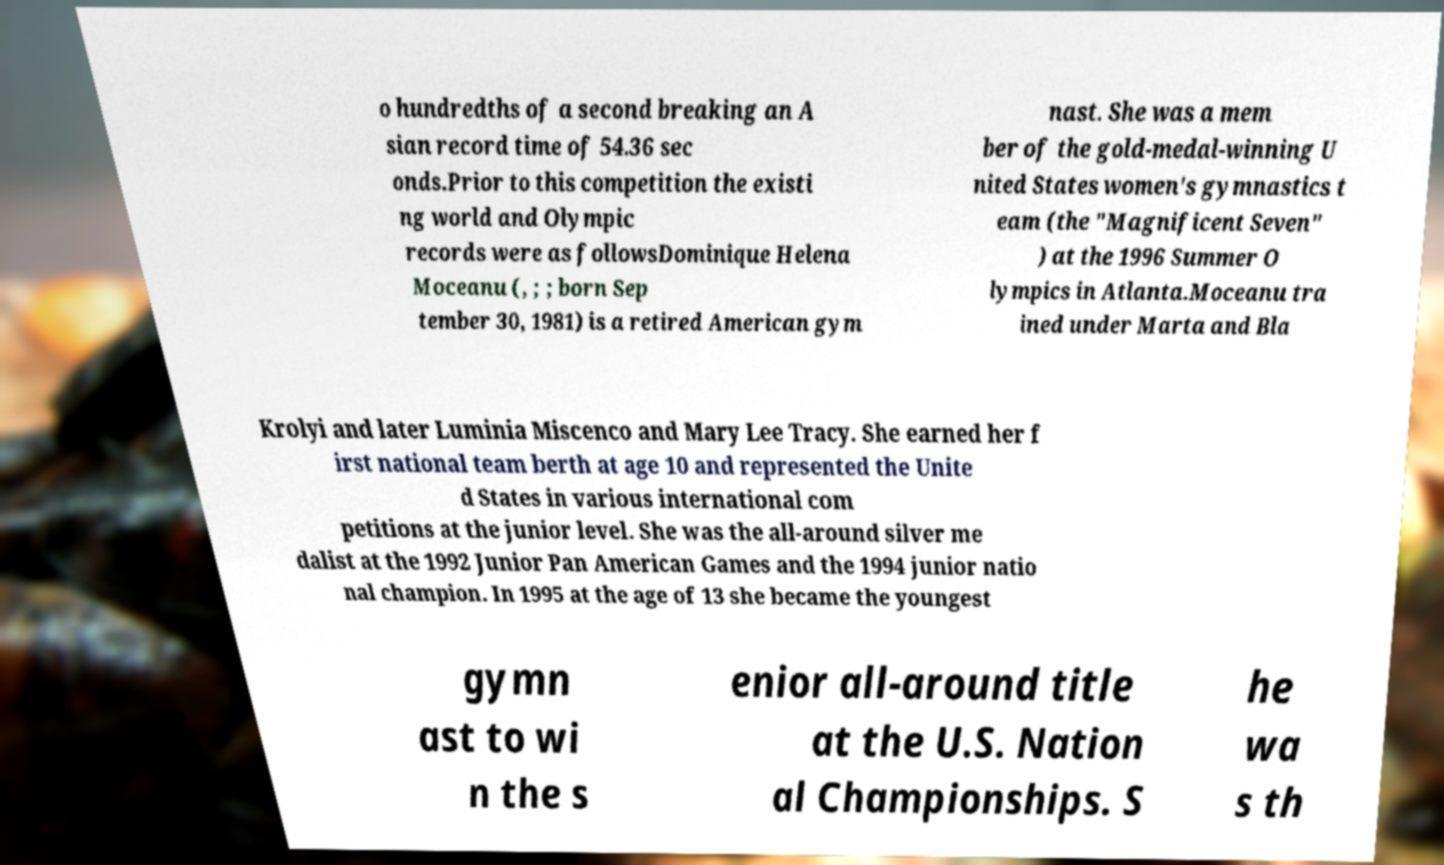What messages or text are displayed in this image? I need them in a readable, typed format. o hundredths of a second breaking an A sian record time of 54.36 sec onds.Prior to this competition the existi ng world and Olympic records were as followsDominique Helena Moceanu (, ; ; born Sep tember 30, 1981) is a retired American gym nast. She was a mem ber of the gold-medal-winning U nited States women's gymnastics t eam (the "Magnificent Seven" ) at the 1996 Summer O lympics in Atlanta.Moceanu tra ined under Marta and Bla Krolyi and later Luminia Miscenco and Mary Lee Tracy. She earned her f irst national team berth at age 10 and represented the Unite d States in various international com petitions at the junior level. She was the all-around silver me dalist at the 1992 Junior Pan American Games and the 1994 junior natio nal champion. In 1995 at the age of 13 she became the youngest gymn ast to wi n the s enior all-around title at the U.S. Nation al Championships. S he wa s th 